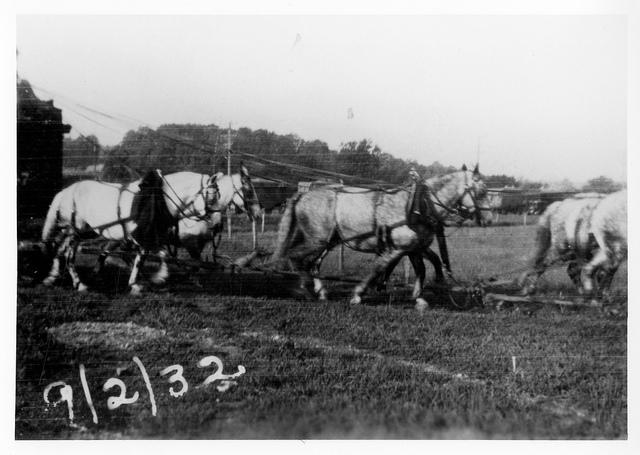What date was this photo taken?
Give a very brief answer. 9/2/32. How many horses in the photo?
Give a very brief answer. 6. What kind of animals are pictured?
Concise answer only. Horses. Is the person on the horse's back?
Answer briefly. No. What year is on this picture?
Quick response, please. 1932. What are these horses pulling?
Write a very short answer. Wagon. What are the horses wearing?
Concise answer only. Saddles. 